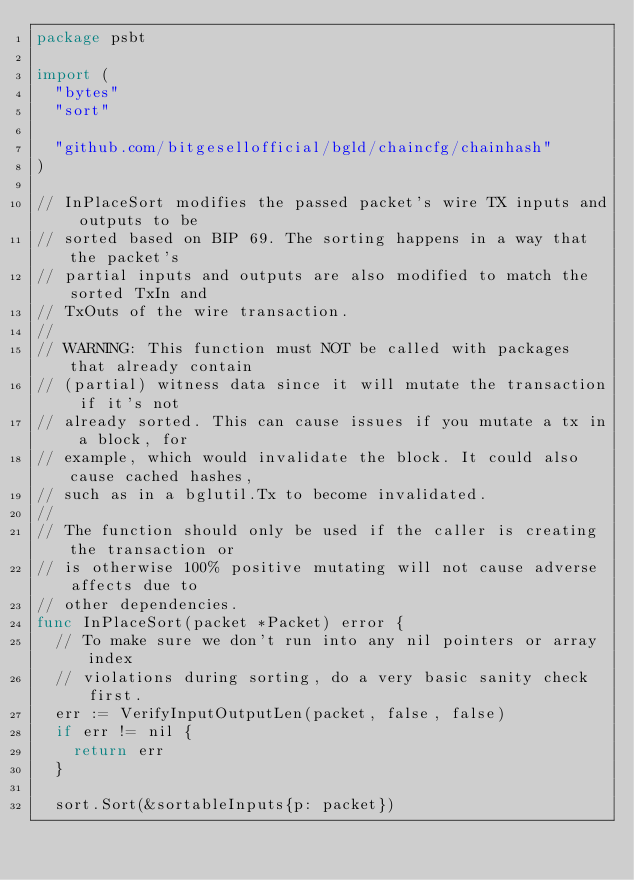<code> <loc_0><loc_0><loc_500><loc_500><_Go_>package psbt

import (
	"bytes"
	"sort"

	"github.com/bitgesellofficial/bgld/chaincfg/chainhash"
)

// InPlaceSort modifies the passed packet's wire TX inputs and outputs to be
// sorted based on BIP 69. The sorting happens in a way that the packet's
// partial inputs and outputs are also modified to match the sorted TxIn and
// TxOuts of the wire transaction.
//
// WARNING: This function must NOT be called with packages that already contain
// (partial) witness data since it will mutate the transaction if it's not
// already sorted. This can cause issues if you mutate a tx in a block, for
// example, which would invalidate the block. It could also cause cached hashes,
// such as in a bglutil.Tx to become invalidated.
//
// The function should only be used if the caller is creating the transaction or
// is otherwise 100% positive mutating will not cause adverse affects due to
// other dependencies.
func InPlaceSort(packet *Packet) error {
	// To make sure we don't run into any nil pointers or array index
	// violations during sorting, do a very basic sanity check first.
	err := VerifyInputOutputLen(packet, false, false)
	if err != nil {
		return err
	}

	sort.Sort(&sortableInputs{p: packet})</code> 